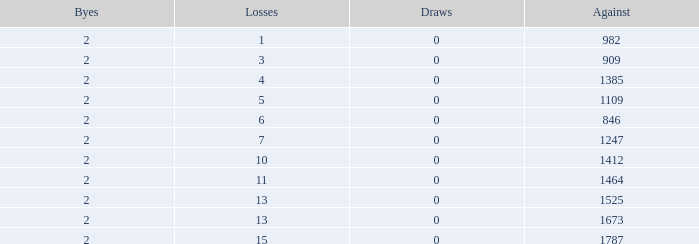What is the number listed under against when there were less than 13 losses and less than 2 byes? 0.0. 